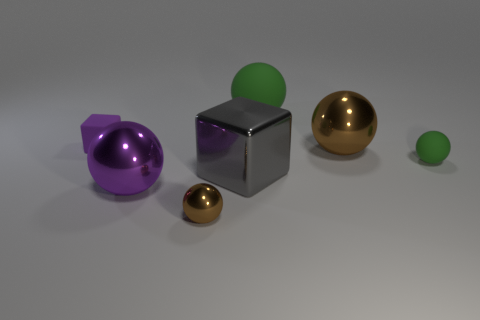Subtract 3 balls. How many balls are left? 2 Subtract all rubber spheres. How many spheres are left? 3 Subtract all green balls. How many balls are left? 3 Subtract all yellow balls. Subtract all red cubes. How many balls are left? 5 Add 2 tiny brown spheres. How many objects exist? 9 Subtract all cubes. How many objects are left? 5 Add 5 big gray rubber cubes. How many big gray rubber cubes exist? 5 Subtract 0 cyan blocks. How many objects are left? 7 Subtract all large blue cubes. Subtract all small brown spheres. How many objects are left? 6 Add 3 big purple objects. How many big purple objects are left? 4 